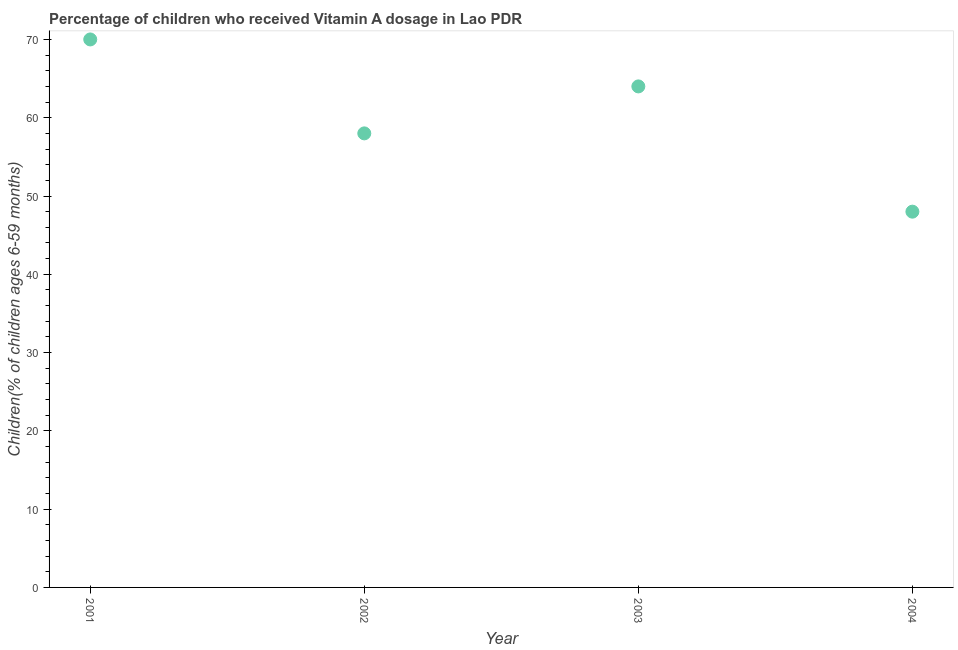Across all years, what is the minimum vitamin a supplementation coverage rate?
Your answer should be compact. 48. In which year was the vitamin a supplementation coverage rate minimum?
Provide a short and direct response. 2004. What is the sum of the vitamin a supplementation coverage rate?
Give a very brief answer. 240. What is the difference between the vitamin a supplementation coverage rate in 2003 and 2004?
Your answer should be very brief. 16. What is the average vitamin a supplementation coverage rate per year?
Keep it short and to the point. 60. What is the median vitamin a supplementation coverage rate?
Keep it short and to the point. 61. Do a majority of the years between 2003 and 2002 (inclusive) have vitamin a supplementation coverage rate greater than 12 %?
Provide a succinct answer. No. What is the ratio of the vitamin a supplementation coverage rate in 2001 to that in 2004?
Ensure brevity in your answer.  1.46. Is the difference between the vitamin a supplementation coverage rate in 2003 and 2004 greater than the difference between any two years?
Give a very brief answer. No. In how many years, is the vitamin a supplementation coverage rate greater than the average vitamin a supplementation coverage rate taken over all years?
Keep it short and to the point. 2. Does the vitamin a supplementation coverage rate monotonically increase over the years?
Your answer should be compact. No. What is the difference between two consecutive major ticks on the Y-axis?
Provide a short and direct response. 10. Are the values on the major ticks of Y-axis written in scientific E-notation?
Give a very brief answer. No. Does the graph contain grids?
Make the answer very short. No. What is the title of the graph?
Ensure brevity in your answer.  Percentage of children who received Vitamin A dosage in Lao PDR. What is the label or title of the X-axis?
Make the answer very short. Year. What is the label or title of the Y-axis?
Ensure brevity in your answer.  Children(% of children ages 6-59 months). What is the Children(% of children ages 6-59 months) in 2003?
Give a very brief answer. 64. What is the difference between the Children(% of children ages 6-59 months) in 2001 and 2004?
Your response must be concise. 22. What is the difference between the Children(% of children ages 6-59 months) in 2002 and 2003?
Give a very brief answer. -6. What is the ratio of the Children(% of children ages 6-59 months) in 2001 to that in 2002?
Make the answer very short. 1.21. What is the ratio of the Children(% of children ages 6-59 months) in 2001 to that in 2003?
Offer a terse response. 1.09. What is the ratio of the Children(% of children ages 6-59 months) in 2001 to that in 2004?
Your answer should be very brief. 1.46. What is the ratio of the Children(% of children ages 6-59 months) in 2002 to that in 2003?
Keep it short and to the point. 0.91. What is the ratio of the Children(% of children ages 6-59 months) in 2002 to that in 2004?
Offer a terse response. 1.21. What is the ratio of the Children(% of children ages 6-59 months) in 2003 to that in 2004?
Provide a short and direct response. 1.33. 